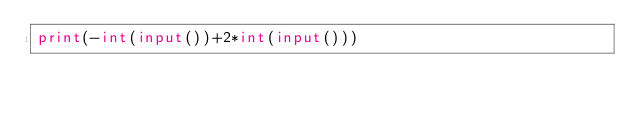<code> <loc_0><loc_0><loc_500><loc_500><_Python_>print(-int(input())+2*int(input()))</code> 